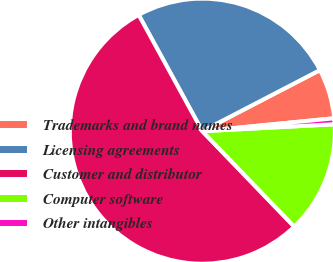Convert chart to OTSL. <chart><loc_0><loc_0><loc_500><loc_500><pie_chart><fcel>Trademarks and brand names<fcel>Licensing agreements<fcel>Customer and distributor<fcel>Computer software<fcel>Other intangibles<nl><fcel>6.07%<fcel>25.35%<fcel>54.23%<fcel>13.63%<fcel>0.72%<nl></chart> 